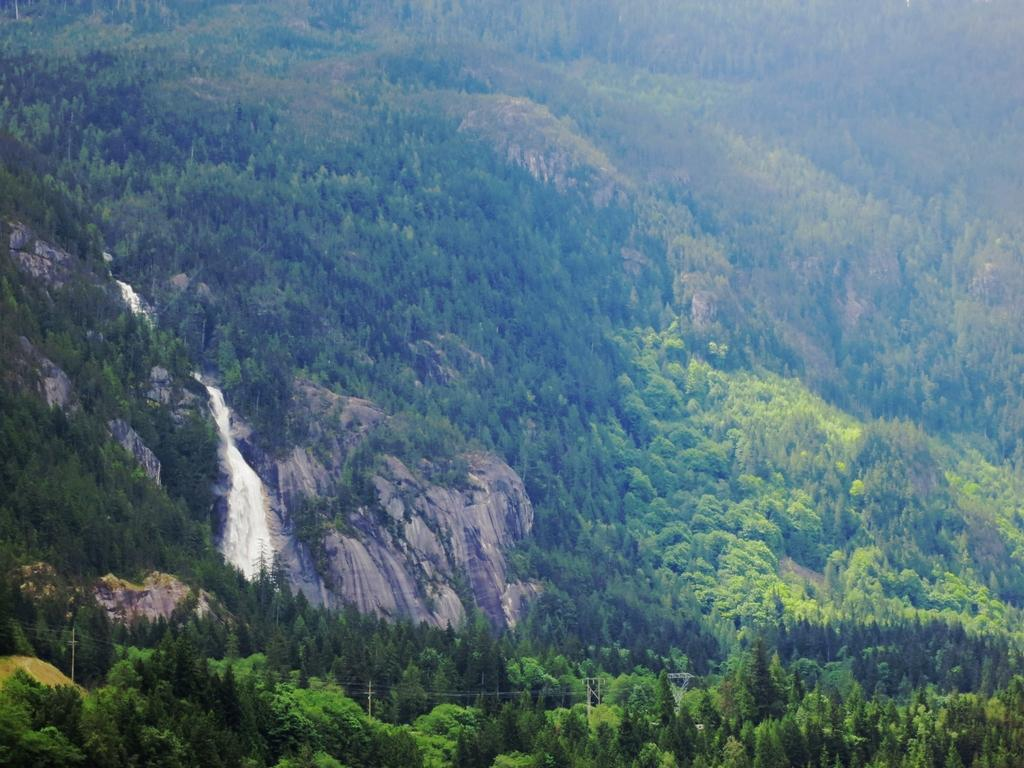What type of natural elements can be seen in the middle of the image? There are trees, hills, stones, and a waterfall in the middle of the image. Can you describe the landscape in the image? The landscape in the image includes trees, hills, stones, and a waterfall. What might be the source of the waterfall in the image? The source of the waterfall in the image is not visible, but it could be from a higher elevation or a nearby body of water. What type of rice is being cooked in the image? There is no rice present in the image; it features trees, hills, stones, and a waterfall. What suggestion is being made in the image? There is no suggestion being made in the image; it is a visual representation of a landscape. 